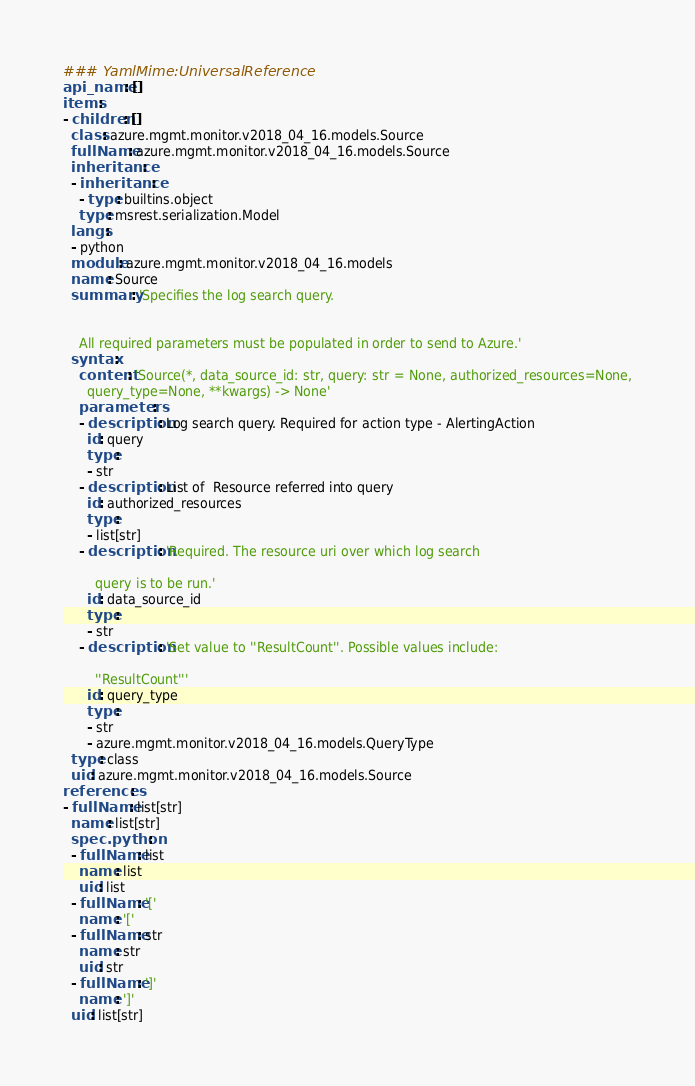<code> <loc_0><loc_0><loc_500><loc_500><_YAML_>### YamlMime:UniversalReference
api_name: []
items:
- children: []
  class: azure.mgmt.monitor.v2018_04_16.models.Source
  fullName: azure.mgmt.monitor.v2018_04_16.models.Source
  inheritance:
  - inheritance:
    - type: builtins.object
    type: msrest.serialization.Model
  langs:
  - python
  module: azure.mgmt.monitor.v2018_04_16.models
  name: Source
  summary: 'Specifies the log search query.


    All required parameters must be populated in order to send to Azure.'
  syntax:
    content: 'Source(*, data_source_id: str, query: str = None, authorized_resources=None,
      query_type=None, **kwargs) -> None'
    parameters:
    - description: Log search query. Required for action type - AlertingAction
      id: query
      type:
      - str
    - description: List of  Resource referred into query
      id: authorized_resources
      type:
      - list[str]
    - description: 'Required. The resource uri over which log search

        query is to be run.'
      id: data_source_id
      type:
      - str
    - description: 'Set value to ''ResultCount''. Possible values include:

        ''ResultCount'''
      id: query_type
      type:
      - str
      - azure.mgmt.monitor.v2018_04_16.models.QueryType
  type: class
  uid: azure.mgmt.monitor.v2018_04_16.models.Source
references:
- fullName: list[str]
  name: list[str]
  spec.python:
  - fullName: list
    name: list
    uid: list
  - fullName: '['
    name: '['
  - fullName: str
    name: str
    uid: str
  - fullName: ']'
    name: ']'
  uid: list[str]
</code> 